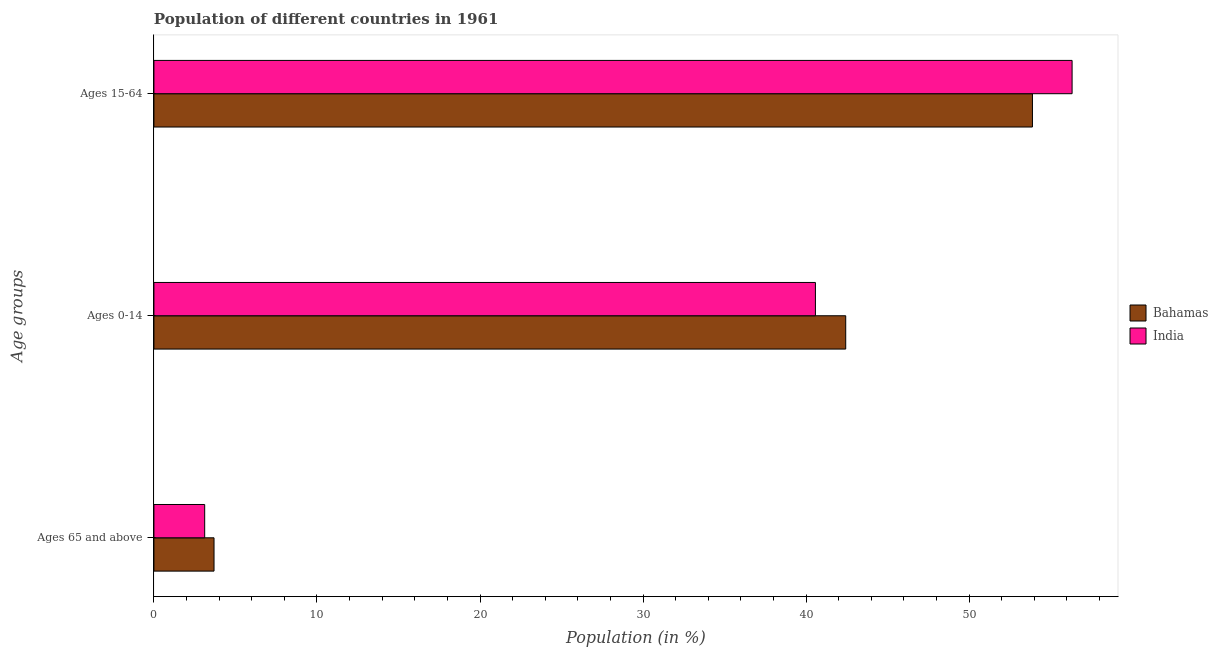How many different coloured bars are there?
Ensure brevity in your answer.  2. Are the number of bars per tick equal to the number of legend labels?
Offer a terse response. Yes. How many bars are there on the 1st tick from the top?
Your response must be concise. 2. What is the label of the 1st group of bars from the top?
Offer a terse response. Ages 15-64. What is the percentage of population within the age-group 15-64 in Bahamas?
Offer a terse response. 53.88. Across all countries, what is the maximum percentage of population within the age-group 15-64?
Your answer should be compact. 56.32. Across all countries, what is the minimum percentage of population within the age-group 15-64?
Your answer should be very brief. 53.88. In which country was the percentage of population within the age-group 0-14 maximum?
Ensure brevity in your answer.  Bahamas. What is the total percentage of population within the age-group 0-14 in the graph?
Offer a very short reply. 83. What is the difference between the percentage of population within the age-group 0-14 in India and that in Bahamas?
Ensure brevity in your answer.  -1.86. What is the difference between the percentage of population within the age-group of 65 and above in India and the percentage of population within the age-group 0-14 in Bahamas?
Provide a succinct answer. -39.32. What is the average percentage of population within the age-group 0-14 per country?
Offer a terse response. 41.5. What is the difference between the percentage of population within the age-group 15-64 and percentage of population within the age-group of 65 and above in India?
Provide a succinct answer. 53.2. What is the ratio of the percentage of population within the age-group of 65 and above in Bahamas to that in India?
Provide a succinct answer. 1.18. Is the difference between the percentage of population within the age-group 15-64 in India and Bahamas greater than the difference between the percentage of population within the age-group 0-14 in India and Bahamas?
Your answer should be very brief. Yes. What is the difference between the highest and the second highest percentage of population within the age-group of 65 and above?
Offer a very short reply. 0.57. What is the difference between the highest and the lowest percentage of population within the age-group 0-14?
Keep it short and to the point. 1.86. In how many countries, is the percentage of population within the age-group 15-64 greater than the average percentage of population within the age-group 15-64 taken over all countries?
Make the answer very short. 1. Is the sum of the percentage of population within the age-group 15-64 in India and Bahamas greater than the maximum percentage of population within the age-group 0-14 across all countries?
Your response must be concise. Yes. What does the 1st bar from the top in Ages 0-14 represents?
Provide a succinct answer. India. What does the 1st bar from the bottom in Ages 0-14 represents?
Offer a terse response. Bahamas. Is it the case that in every country, the sum of the percentage of population within the age-group of 65 and above and percentage of population within the age-group 0-14 is greater than the percentage of population within the age-group 15-64?
Make the answer very short. No. How many countries are there in the graph?
Your response must be concise. 2. Are the values on the major ticks of X-axis written in scientific E-notation?
Provide a succinct answer. No. Does the graph contain any zero values?
Your answer should be very brief. No. Does the graph contain grids?
Provide a short and direct response. No. How many legend labels are there?
Offer a terse response. 2. What is the title of the graph?
Your response must be concise. Population of different countries in 1961. What is the label or title of the Y-axis?
Provide a succinct answer. Age groups. What is the Population (in %) of Bahamas in Ages 65 and above?
Provide a succinct answer. 3.69. What is the Population (in %) of India in Ages 65 and above?
Offer a terse response. 3.11. What is the Population (in %) of Bahamas in Ages 0-14?
Offer a very short reply. 42.43. What is the Population (in %) in India in Ages 0-14?
Provide a short and direct response. 40.57. What is the Population (in %) of Bahamas in Ages 15-64?
Make the answer very short. 53.88. What is the Population (in %) in India in Ages 15-64?
Provide a short and direct response. 56.32. Across all Age groups, what is the maximum Population (in %) of Bahamas?
Give a very brief answer. 53.88. Across all Age groups, what is the maximum Population (in %) in India?
Your answer should be compact. 56.32. Across all Age groups, what is the minimum Population (in %) of Bahamas?
Keep it short and to the point. 3.69. Across all Age groups, what is the minimum Population (in %) of India?
Your answer should be compact. 3.11. What is the total Population (in %) of Bahamas in the graph?
Ensure brevity in your answer.  100. What is the difference between the Population (in %) of Bahamas in Ages 65 and above and that in Ages 0-14?
Offer a very short reply. -38.74. What is the difference between the Population (in %) of India in Ages 65 and above and that in Ages 0-14?
Make the answer very short. -37.46. What is the difference between the Population (in %) in Bahamas in Ages 65 and above and that in Ages 15-64?
Give a very brief answer. -50.2. What is the difference between the Population (in %) in India in Ages 65 and above and that in Ages 15-64?
Provide a short and direct response. -53.2. What is the difference between the Population (in %) in Bahamas in Ages 0-14 and that in Ages 15-64?
Offer a very short reply. -11.45. What is the difference between the Population (in %) in India in Ages 0-14 and that in Ages 15-64?
Your answer should be compact. -15.74. What is the difference between the Population (in %) in Bahamas in Ages 65 and above and the Population (in %) in India in Ages 0-14?
Provide a short and direct response. -36.89. What is the difference between the Population (in %) in Bahamas in Ages 65 and above and the Population (in %) in India in Ages 15-64?
Ensure brevity in your answer.  -52.63. What is the difference between the Population (in %) in Bahamas in Ages 0-14 and the Population (in %) in India in Ages 15-64?
Your answer should be compact. -13.88. What is the average Population (in %) of Bahamas per Age groups?
Ensure brevity in your answer.  33.33. What is the average Population (in %) in India per Age groups?
Give a very brief answer. 33.33. What is the difference between the Population (in %) of Bahamas and Population (in %) of India in Ages 65 and above?
Your answer should be very brief. 0.57. What is the difference between the Population (in %) in Bahamas and Population (in %) in India in Ages 0-14?
Your response must be concise. 1.86. What is the difference between the Population (in %) in Bahamas and Population (in %) in India in Ages 15-64?
Ensure brevity in your answer.  -2.43. What is the ratio of the Population (in %) in Bahamas in Ages 65 and above to that in Ages 0-14?
Make the answer very short. 0.09. What is the ratio of the Population (in %) in India in Ages 65 and above to that in Ages 0-14?
Provide a succinct answer. 0.08. What is the ratio of the Population (in %) in Bahamas in Ages 65 and above to that in Ages 15-64?
Make the answer very short. 0.07. What is the ratio of the Population (in %) of India in Ages 65 and above to that in Ages 15-64?
Offer a very short reply. 0.06. What is the ratio of the Population (in %) in Bahamas in Ages 0-14 to that in Ages 15-64?
Your answer should be compact. 0.79. What is the ratio of the Population (in %) of India in Ages 0-14 to that in Ages 15-64?
Provide a succinct answer. 0.72. What is the difference between the highest and the second highest Population (in %) of Bahamas?
Provide a succinct answer. 11.45. What is the difference between the highest and the second highest Population (in %) in India?
Provide a succinct answer. 15.74. What is the difference between the highest and the lowest Population (in %) in Bahamas?
Provide a succinct answer. 50.2. What is the difference between the highest and the lowest Population (in %) of India?
Keep it short and to the point. 53.2. 